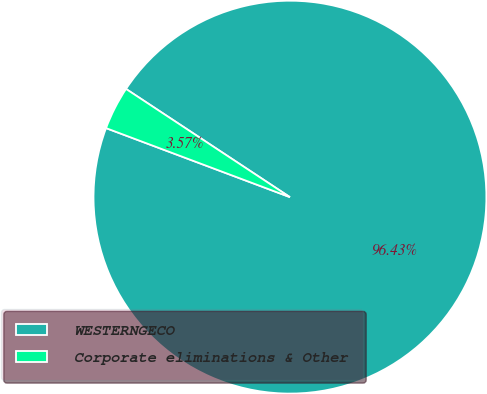<chart> <loc_0><loc_0><loc_500><loc_500><pie_chart><fcel>WESTERNGECO<fcel>Corporate eliminations & Other<nl><fcel>96.43%<fcel>3.57%<nl></chart> 